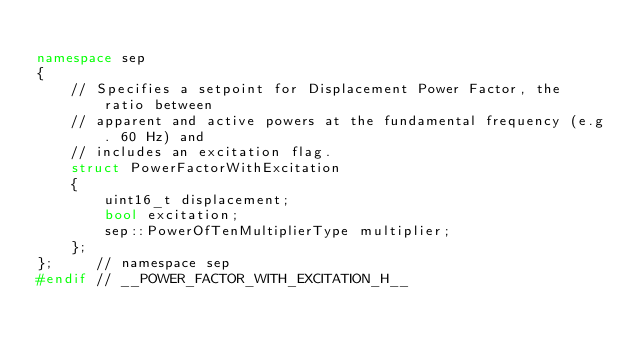<code> <loc_0><loc_0><loc_500><loc_500><_C++_>
namespace sep
{
    // Specifies a setpoint for Displacement Power Factor, the ratio between
    // apparent and active powers at the fundamental frequency (e.g. 60 Hz) and
    // includes an excitation flag.
    struct PowerFactorWithExcitation
    {
        uint16_t displacement;
        bool excitation;
        sep::PowerOfTenMultiplierType multiplier;
    };
};     // namespace sep
#endif // __POWER_FACTOR_WITH_EXCITATION_H__</code> 